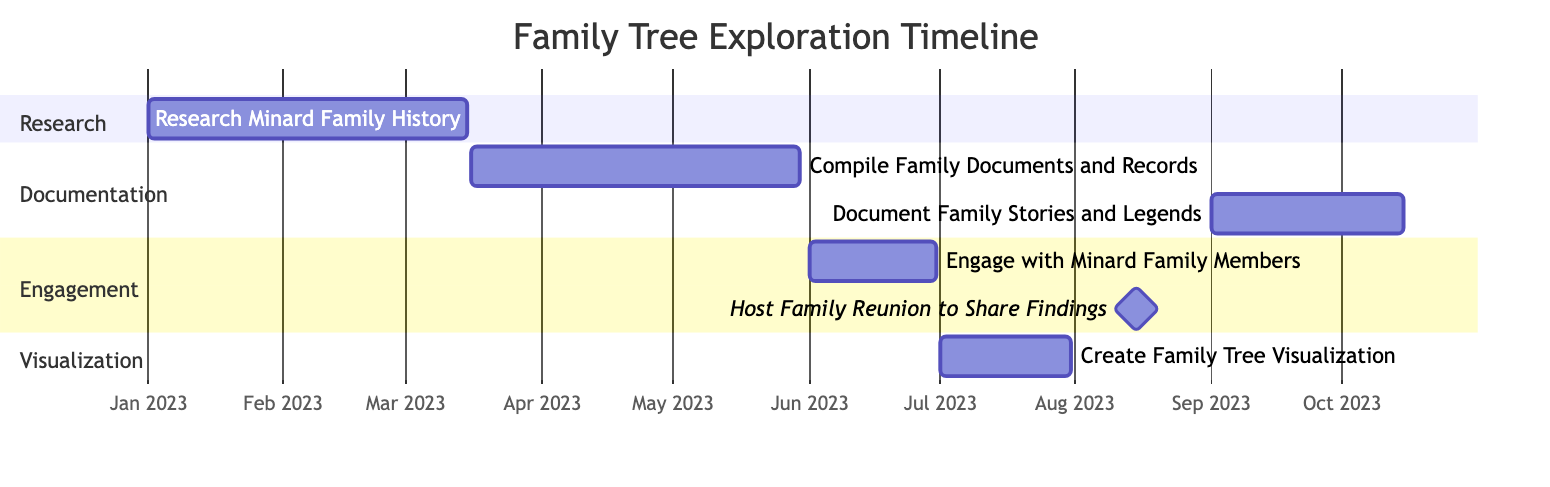What is the duration of the "Research Minard Family History" task? The task starts on January 1, 2023, and ends on March 15, 2023. To find the duration, we calculate the number of days between these two dates, which is 73 days.
Answer: 73 days Which task occurs immediately before the "Host Family Reunion to Share Findings"? The "Engage with Minard Family Members" task starts on June 1, 2023, and ends on June 30, 2023. Since the "Host Family Reunion" is on August 15, 2023, the task directly before it is the engagement task.
Answer: Engage with Minard Family Members What is the total number of tasks in the timeline? There are six tasks listed in the timeline: Research Minard Family History, Compile Family Documents and Records, Engage with Minard Family Members, Create Family Tree Visualization, Host Family Reunion to Share Findings, and Document Family Stories and Legends. Therefore, we count them up to find the total.
Answer: 6 When does the "Document Family Stories and Legends" task end? This task starts on September 1, 2023, and ends on October 15, 2023. The question specifically asks for the ending date. Thus, the answer is found directly in the timeline.
Answer: October 15, 2023 Which section has the longest duration task? The "Documentation" section contains the "Compile Family Documents and Records" task, which lasts from March 16 to May 30, totaling 75 days, and "Document Family Stories and Legends," which lasts for 45 days. Comparing the durations, "Compile Family Documents and Records" is longer.
Answer: Documentation 